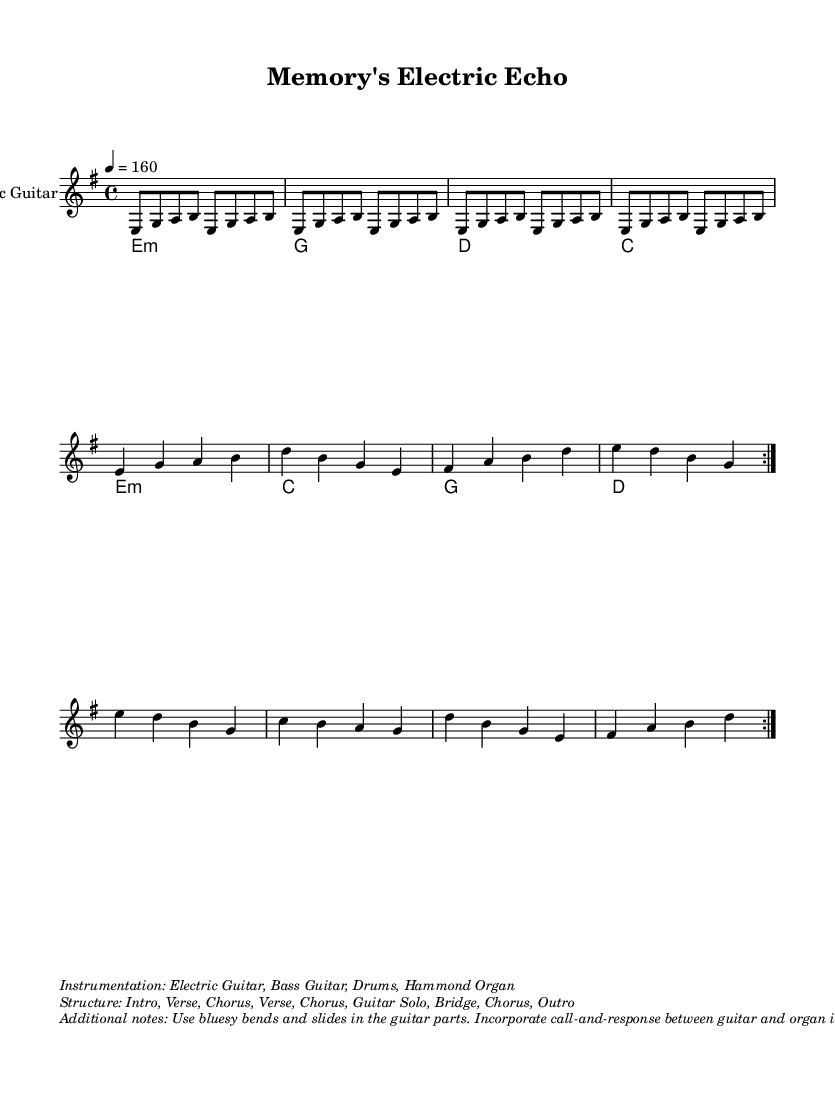What is the key signature of this music? The key signature indicates E minor, identified by one sharp on the F line. Since the notation shows we are in E minor, this points to its related major key being G major.
Answer: E minor What is the time signature of this music? The time signature is indicated as 4/4, which means there are four beats per measure, and a quarter note gets one beat. This is a common time signature in many music styles.
Answer: 4/4 What is the tempo marking of this piece? The tempo marking is set to 160 bpm (beats per minute), as stated in the tempo directive. This suggests a brisk pace, characteristic of high-energy blues rock.
Answer: 160 How many measures are in the repeat section? There are 8 measures in total for the repeat section, as each instance of the guitar riff and the guitar verse and chorus has four measures each. When repeated, it sums to 8 measures.
Answer: 8 What instrumentation is indicated for this piece? The instrumentation specified includes Electric Guitar, Bass Guitar, Drums, and Hammond Organ. This combination is typical for blues rock and emphasizes the electric aspect.
Answer: Electric Guitar, Bass Guitar, Drums, Hammond Organ What is the structure of this music piece? The structure is laid out as Intro, Verse, Chorus, Verse, Chorus, Guitar Solo, Bridge, Chorus, Outro. This arrangement outlines the flow and development of the piece, essential for understanding live performance dynamics.
Answer: Intro, Verse, Chorus, Verse, Chorus, Guitar Solo, Bridge, Chorus, Outro What specific guitar techniques are suggested in the additional notes? The additional notes recommend using bluesy bends and slides, which are specific techniques that help evoke emotional expression and are commonly used in electric blues guitar playing.
Answer: Bluesy bends and slides 